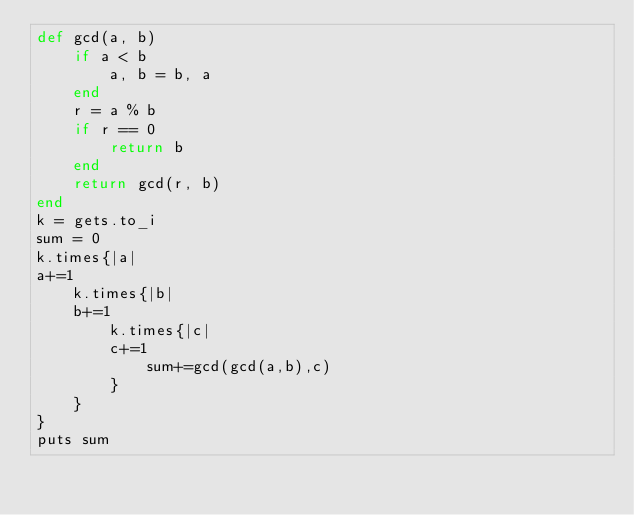<code> <loc_0><loc_0><loc_500><loc_500><_Ruby_>def gcd(a, b)
    if a < b
        a, b = b, a
    end
    r = a % b
    if r == 0
        return b
    end
    return gcd(r, b)
end
k = gets.to_i
sum = 0
k.times{|a|
a+=1
    k.times{|b|
    b+=1
        k.times{|c|
        c+=1
            sum+=gcd(gcd(a,b),c)
        }
    }
}
puts sum</code> 